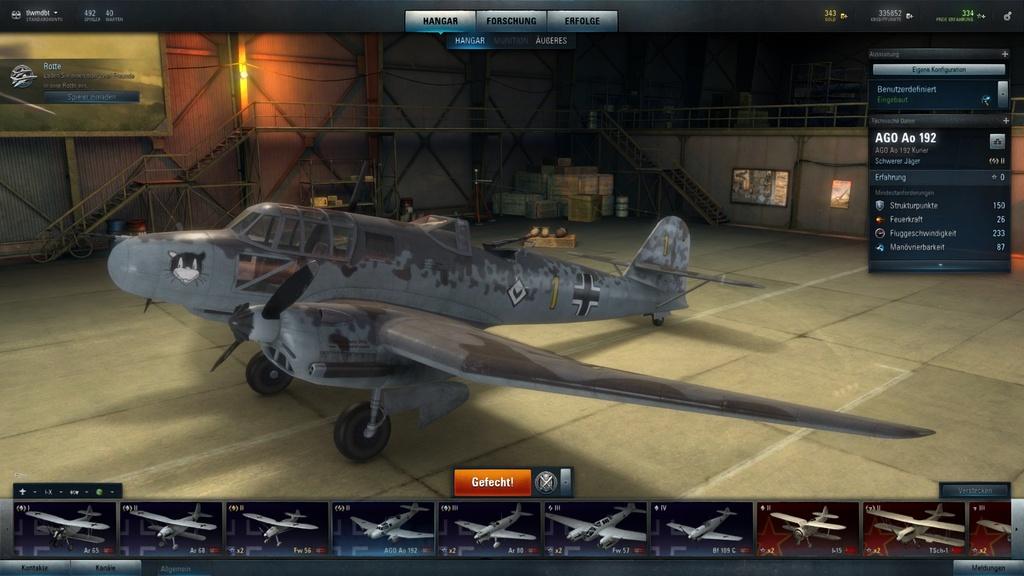What does the button on the top left say?
Keep it short and to the point. Hangar. What does the largest white text say?
Provide a succinct answer. Ago ao 192. 